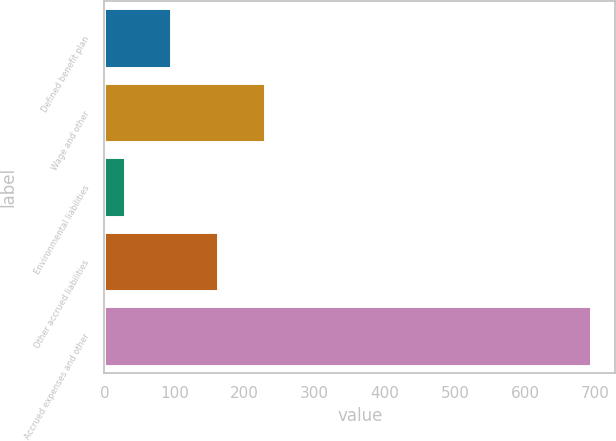Convert chart to OTSL. <chart><loc_0><loc_0><loc_500><loc_500><bar_chart><fcel>Defined benefit plan<fcel>Wage and other<fcel>Environmental liabilities<fcel>Other accrued liabilities<fcel>Accrued expenses and other<nl><fcel>95.5<fcel>228.5<fcel>29<fcel>162<fcel>694<nl></chart> 